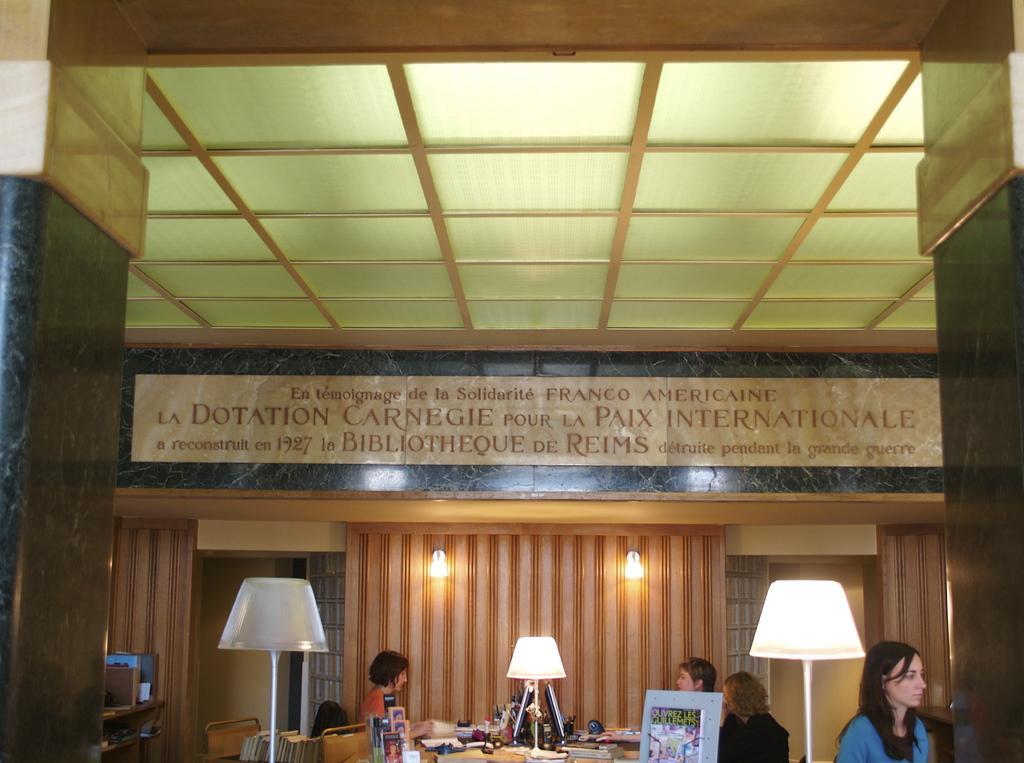How many women are present in the image? There are four women in the image. What type of lighting is present in the image? There are lamps and lights on the wall in the image. What can be found on the table in the image? There are items on a table in the image. What type of reading material is present in the image? There are books in the image. What type of storage is present in the image? There are racks in the image. What type of pizzas are being served to the committee in the image? There is no mention of a committee or pizzas in the image; it features four women, lamps, lights on the wall, items on a table, books, and racks. 